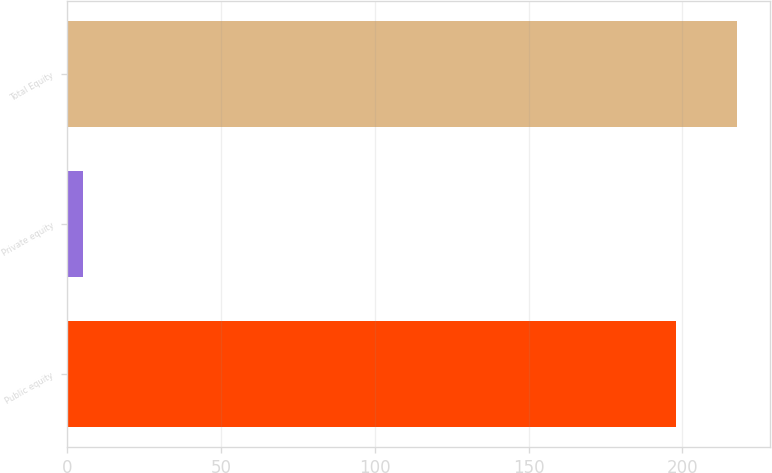Convert chart to OTSL. <chart><loc_0><loc_0><loc_500><loc_500><bar_chart><fcel>Public equity<fcel>Private equity<fcel>Total Equity<nl><fcel>198<fcel>5<fcel>217.8<nl></chart> 